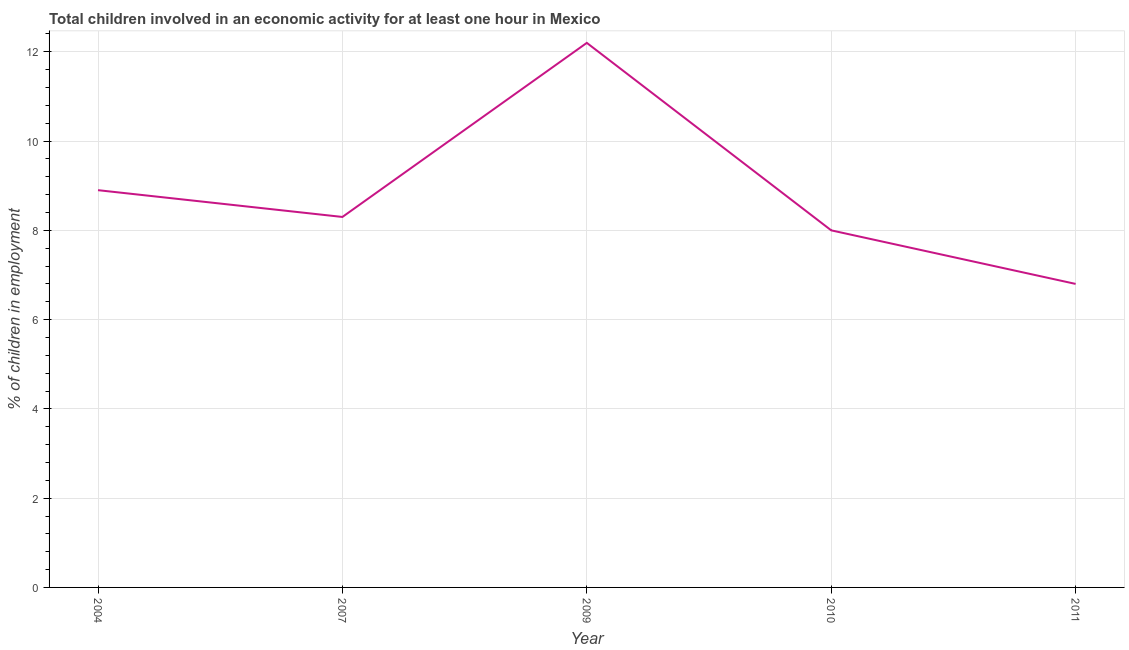In which year was the percentage of children in employment maximum?
Offer a terse response. 2009. In which year was the percentage of children in employment minimum?
Make the answer very short. 2011. What is the sum of the percentage of children in employment?
Ensure brevity in your answer.  44.2. What is the difference between the percentage of children in employment in 2004 and 2011?
Your answer should be very brief. 2.1. What is the average percentage of children in employment per year?
Provide a succinct answer. 8.84. What is the ratio of the percentage of children in employment in 2004 to that in 2009?
Offer a very short reply. 0.73. Is the percentage of children in employment in 2007 less than that in 2010?
Make the answer very short. No. Is the difference between the percentage of children in employment in 2007 and 2011 greater than the difference between any two years?
Your answer should be very brief. No. What is the difference between the highest and the second highest percentage of children in employment?
Ensure brevity in your answer.  3.3. Is the sum of the percentage of children in employment in 2004 and 2007 greater than the maximum percentage of children in employment across all years?
Your response must be concise. Yes. What is the difference between the highest and the lowest percentage of children in employment?
Offer a very short reply. 5.4. How many lines are there?
Provide a succinct answer. 1. What is the difference between two consecutive major ticks on the Y-axis?
Offer a terse response. 2. What is the title of the graph?
Keep it short and to the point. Total children involved in an economic activity for at least one hour in Mexico. What is the label or title of the Y-axis?
Give a very brief answer. % of children in employment. What is the % of children in employment of 2004?
Offer a terse response. 8.9. What is the % of children in employment of 2007?
Provide a succinct answer. 8.3. What is the % of children in employment of 2010?
Keep it short and to the point. 8. What is the % of children in employment in 2011?
Make the answer very short. 6.8. What is the difference between the % of children in employment in 2004 and 2010?
Your response must be concise. 0.9. What is the difference between the % of children in employment in 2009 and 2010?
Provide a short and direct response. 4.2. What is the difference between the % of children in employment in 2009 and 2011?
Your answer should be very brief. 5.4. What is the difference between the % of children in employment in 2010 and 2011?
Ensure brevity in your answer.  1.2. What is the ratio of the % of children in employment in 2004 to that in 2007?
Provide a short and direct response. 1.07. What is the ratio of the % of children in employment in 2004 to that in 2009?
Offer a very short reply. 0.73. What is the ratio of the % of children in employment in 2004 to that in 2010?
Provide a succinct answer. 1.11. What is the ratio of the % of children in employment in 2004 to that in 2011?
Give a very brief answer. 1.31. What is the ratio of the % of children in employment in 2007 to that in 2009?
Your answer should be very brief. 0.68. What is the ratio of the % of children in employment in 2007 to that in 2010?
Ensure brevity in your answer.  1.04. What is the ratio of the % of children in employment in 2007 to that in 2011?
Give a very brief answer. 1.22. What is the ratio of the % of children in employment in 2009 to that in 2010?
Make the answer very short. 1.52. What is the ratio of the % of children in employment in 2009 to that in 2011?
Your answer should be compact. 1.79. What is the ratio of the % of children in employment in 2010 to that in 2011?
Offer a terse response. 1.18. 